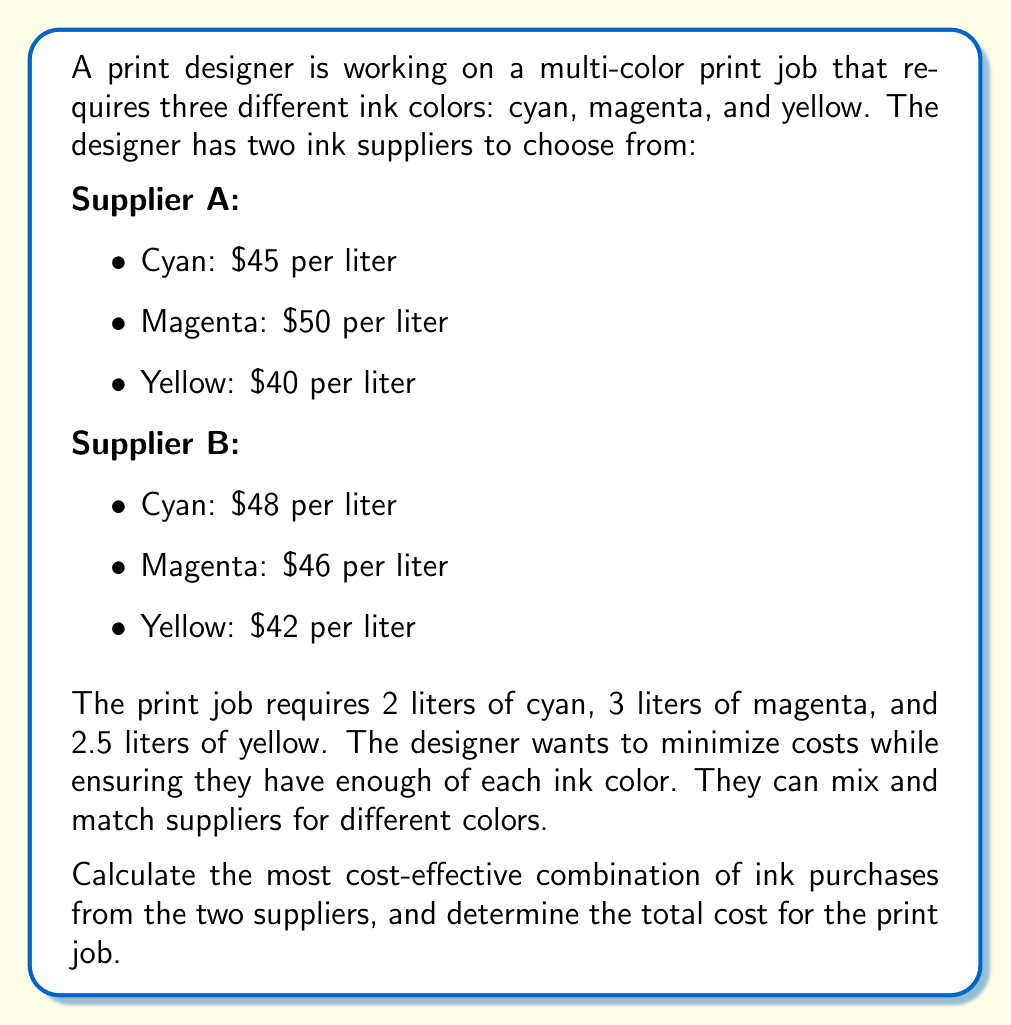What is the answer to this math problem? To solve this problem, we need to compare the costs of each ink color from both suppliers and choose the cheapest option for each color. Then, we'll calculate the total cost based on the required quantities.

Let's break it down by color:

1. Cyan:
   Supplier A: $45 per liter
   Supplier B: $48 per liter
   Cheaper option: Supplier A
   Required amount: 2 liters
   Cost: $45 * 2 = $90

2. Magenta:
   Supplier A: $50 per liter
   Supplier B: $46 per liter
   Cheaper option: Supplier B
   Required amount: 3 liters
   Cost: $46 * 3 = $138

3. Yellow:
   Supplier A: $40 per liter
   Supplier B: $42 per liter
   Cheaper option: Supplier A
   Required amount: 2.5 liters
   Cost: $40 * 2.5 = $100

Now, let's calculate the total cost:

$$\text{Total Cost} = \text{Cyan Cost} + \text{Magenta Cost} + \text{Yellow Cost}$$
$$\text{Total Cost} = $90 + $138 + $100 = $328$$

The most cost-effective combination is:
- Cyan: 2 liters from Supplier A
- Magenta: 3 liters from Supplier B
- Yellow: 2.5 liters from Supplier A
Answer: The most cost-effective combination of ink purchases is to buy cyan and yellow from Supplier A, and magenta from Supplier B. The total cost for the print job is $328. 